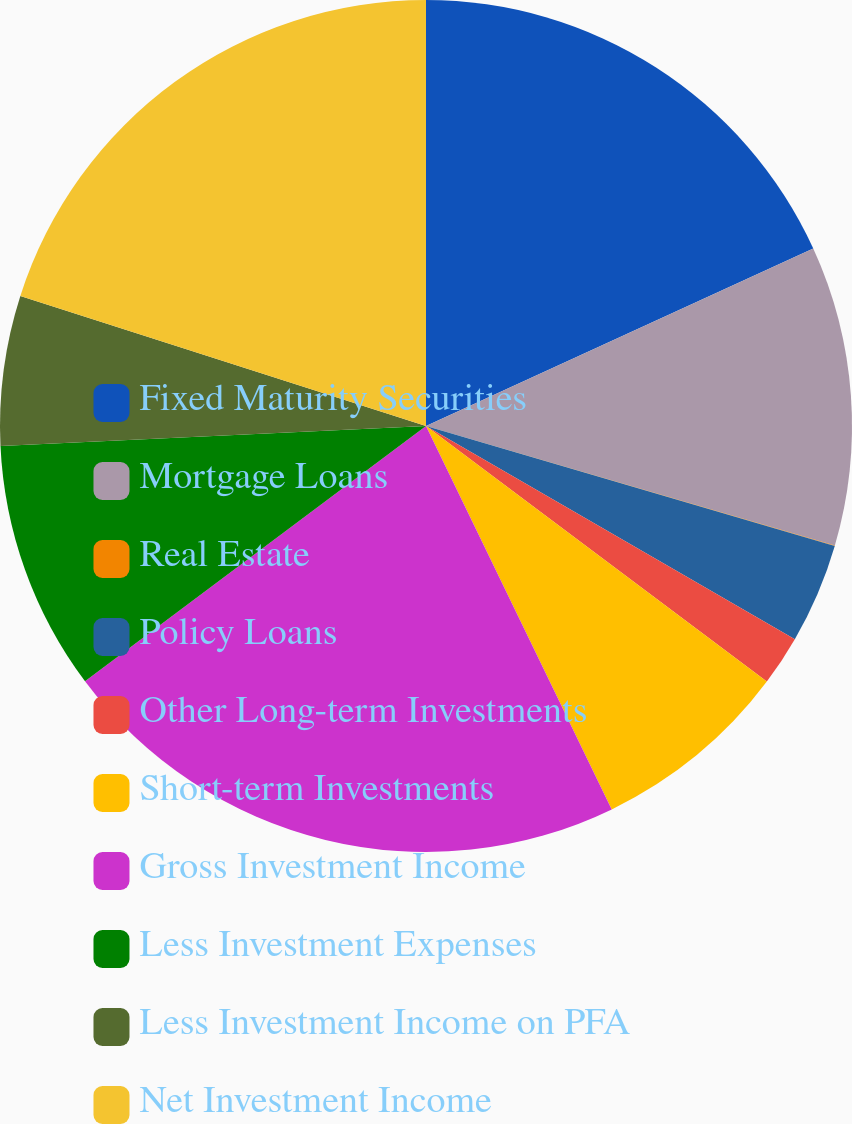<chart> <loc_0><loc_0><loc_500><loc_500><pie_chart><fcel>Fixed Maturity Securities<fcel>Mortgage Loans<fcel>Real Estate<fcel>Policy Loans<fcel>Other Long-term Investments<fcel>Short-term Investments<fcel>Gross Investment Income<fcel>Less Investment Expenses<fcel>Less Investment Income on PFA<fcel>Net Investment Income<nl><fcel>18.16%<fcel>11.37%<fcel>0.01%<fcel>3.8%<fcel>1.9%<fcel>7.58%<fcel>21.95%<fcel>9.48%<fcel>5.69%<fcel>20.06%<nl></chart> 